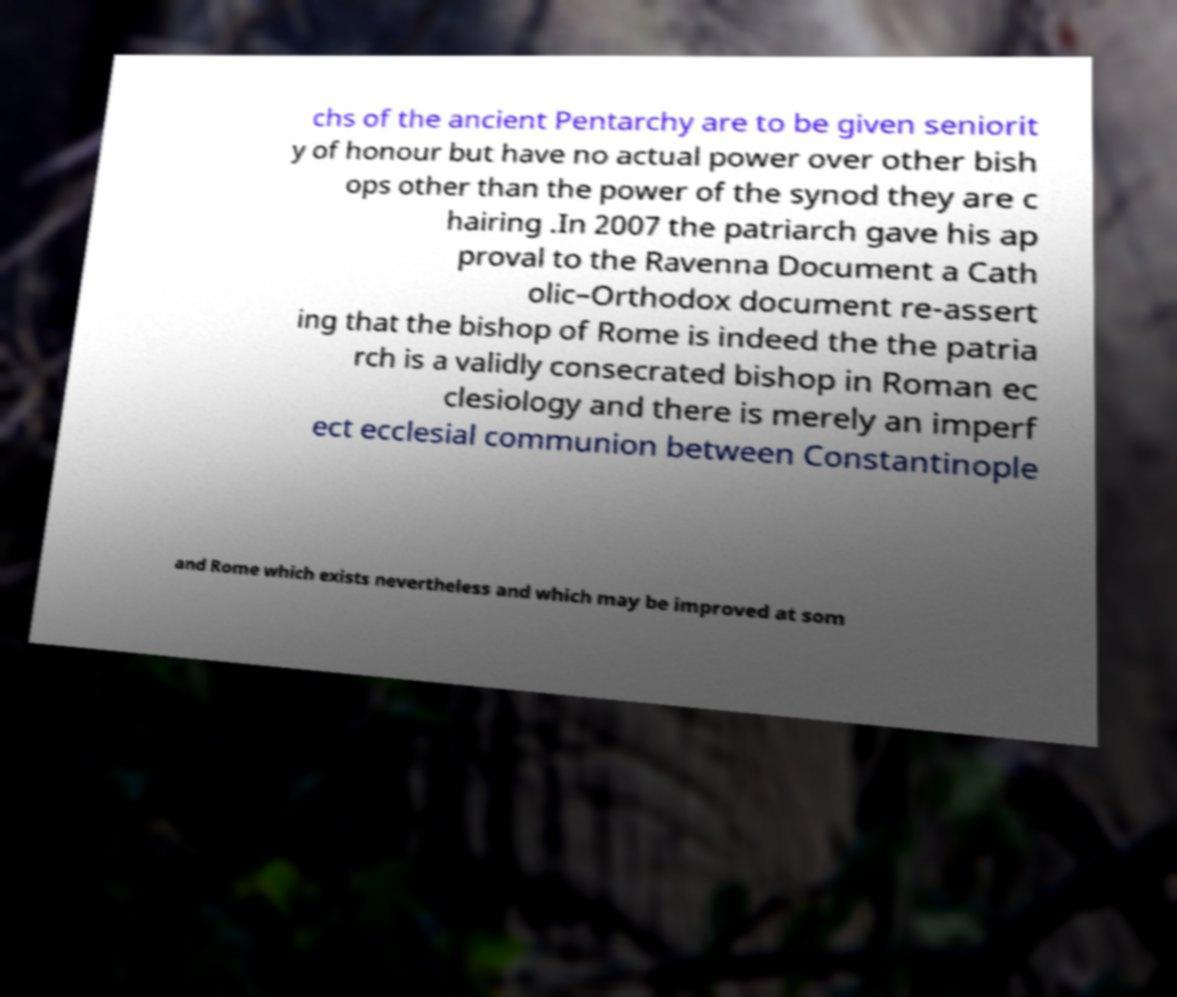Can you read and provide the text displayed in the image?This photo seems to have some interesting text. Can you extract and type it out for me? chs of the ancient Pentarchy are to be given seniorit y of honour but have no actual power over other bish ops other than the power of the synod they are c hairing .In 2007 the patriarch gave his ap proval to the Ravenna Document a Cath olic–Orthodox document re-assert ing that the bishop of Rome is indeed the the patria rch is a validly consecrated bishop in Roman ec clesiology and there is merely an imperf ect ecclesial communion between Constantinople and Rome which exists nevertheless and which may be improved at som 